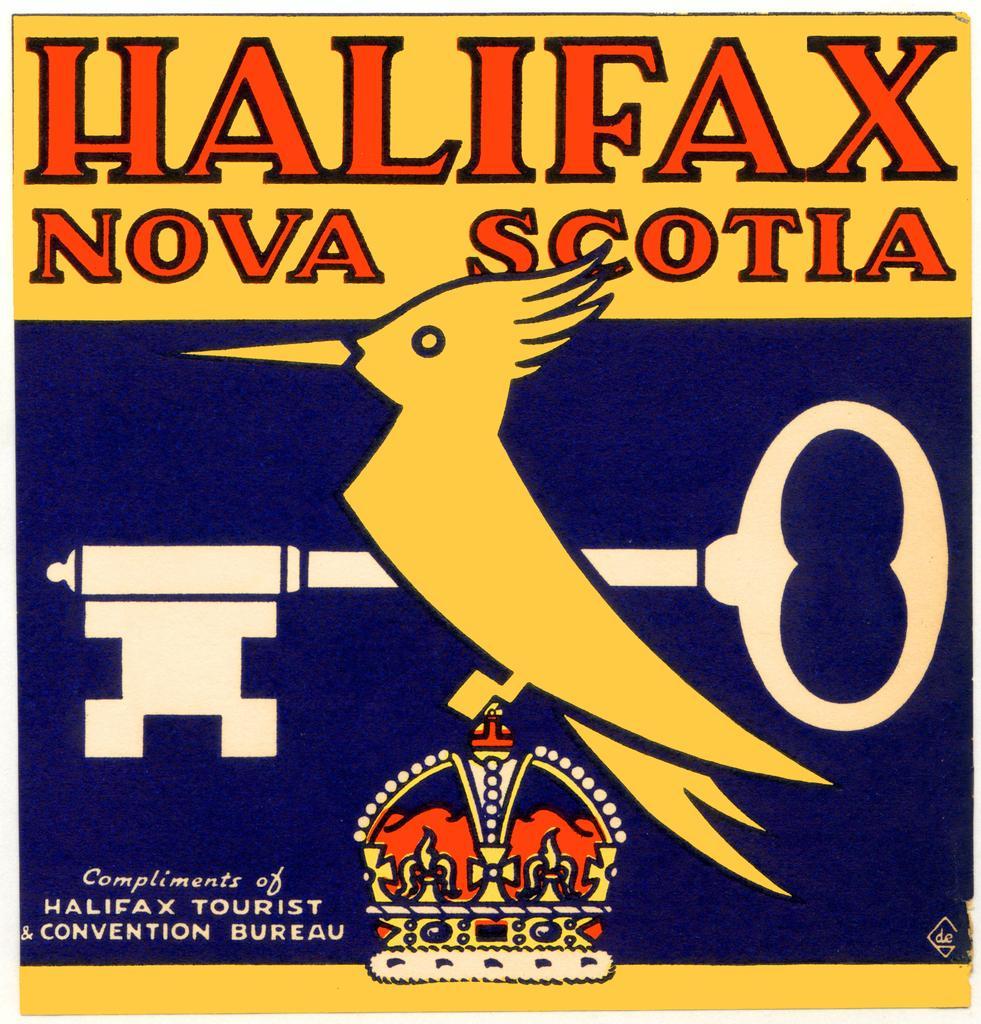Please provide a concise description of this image. This is a poster. On this poster we can see picture of a bird, key, and a crown. There is text written on it. 